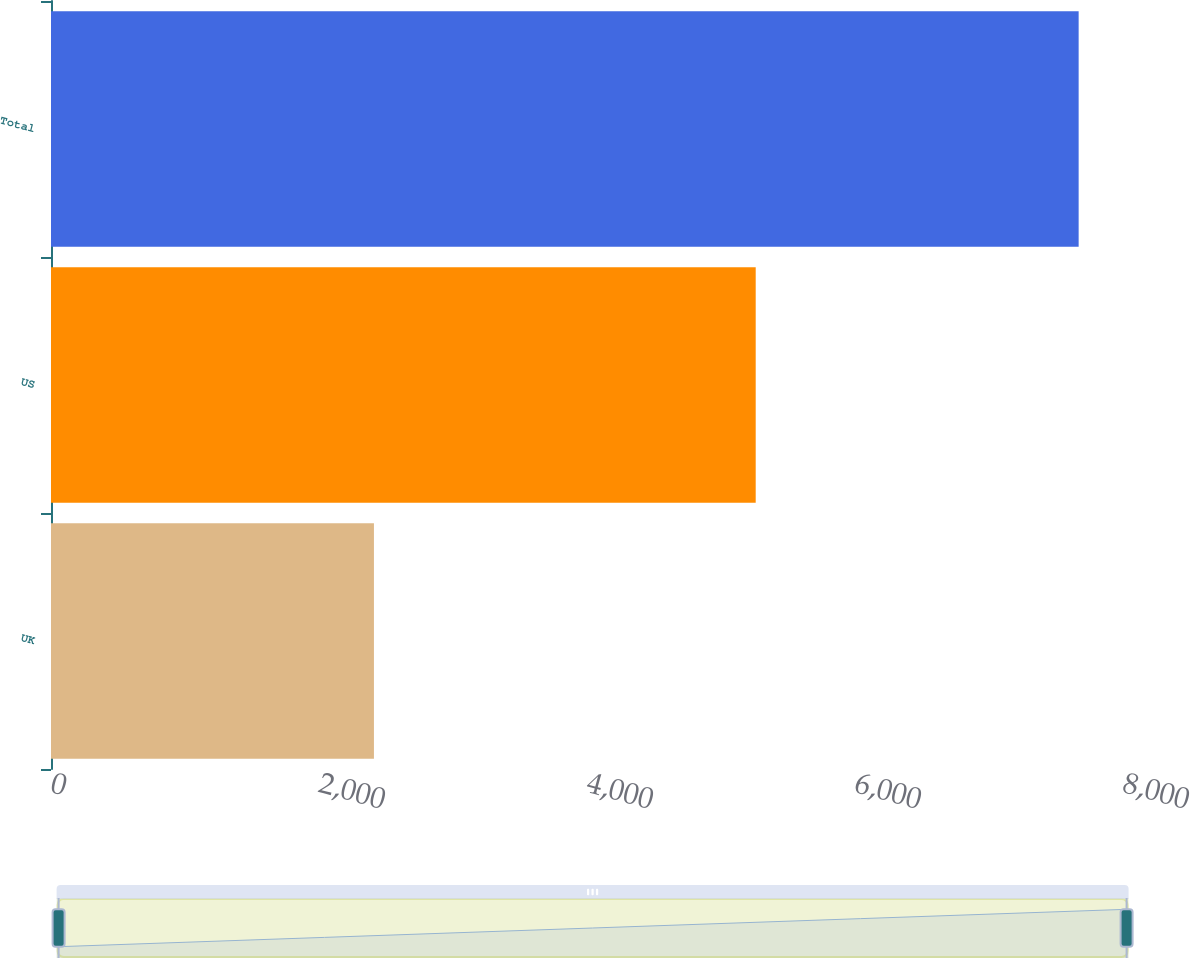Convert chart. <chart><loc_0><loc_0><loc_500><loc_500><bar_chart><fcel>UK<fcel>US<fcel>Total<nl><fcel>2410<fcel>5259<fcel>7669<nl></chart> 